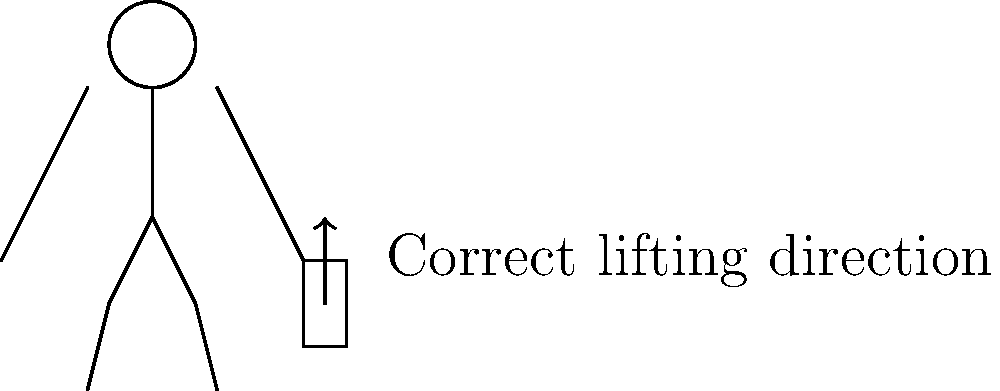When unloading groceries from your minivan, which biomechanical principle should you follow to minimize the risk of back injury? To minimize the risk of back injury when unloading groceries from a minivan, it's important to follow proper body mechanics. Here's a step-by-step explanation of the correct technique:

1. Position yourself close to the vehicle and the groceries to minimize reaching.

2. Bend at the knees and hips, not at the waist. This helps maintain the natural curve of your spine.

3. Keep your back straight and your core muscles engaged throughout the lifting process.

4. Grip the grocery bag or item securely with both hands.

5. Lift the item by straightening your legs, using your leg muscles (quadriceps and hamstrings) to do the work rather than your back muscles.

6. Keep the load close to your body as you lift and carry it.

7. Avoid twisting your spine while lifting. Instead, pivot with your feet to turn.

8. When setting the groceries down, reverse the process: bend at the knees and hips, keeping your back straight.

The key principle here is to use your leg muscles for lifting, rather than your back muscles. This is often referred to as "lifting with your legs, not your back." By doing so, you distribute the weight more evenly and reduce the strain on your spine and back muscles, which are more susceptible to injury when lifting heavy objects.
Answer: Lift with legs, not back 